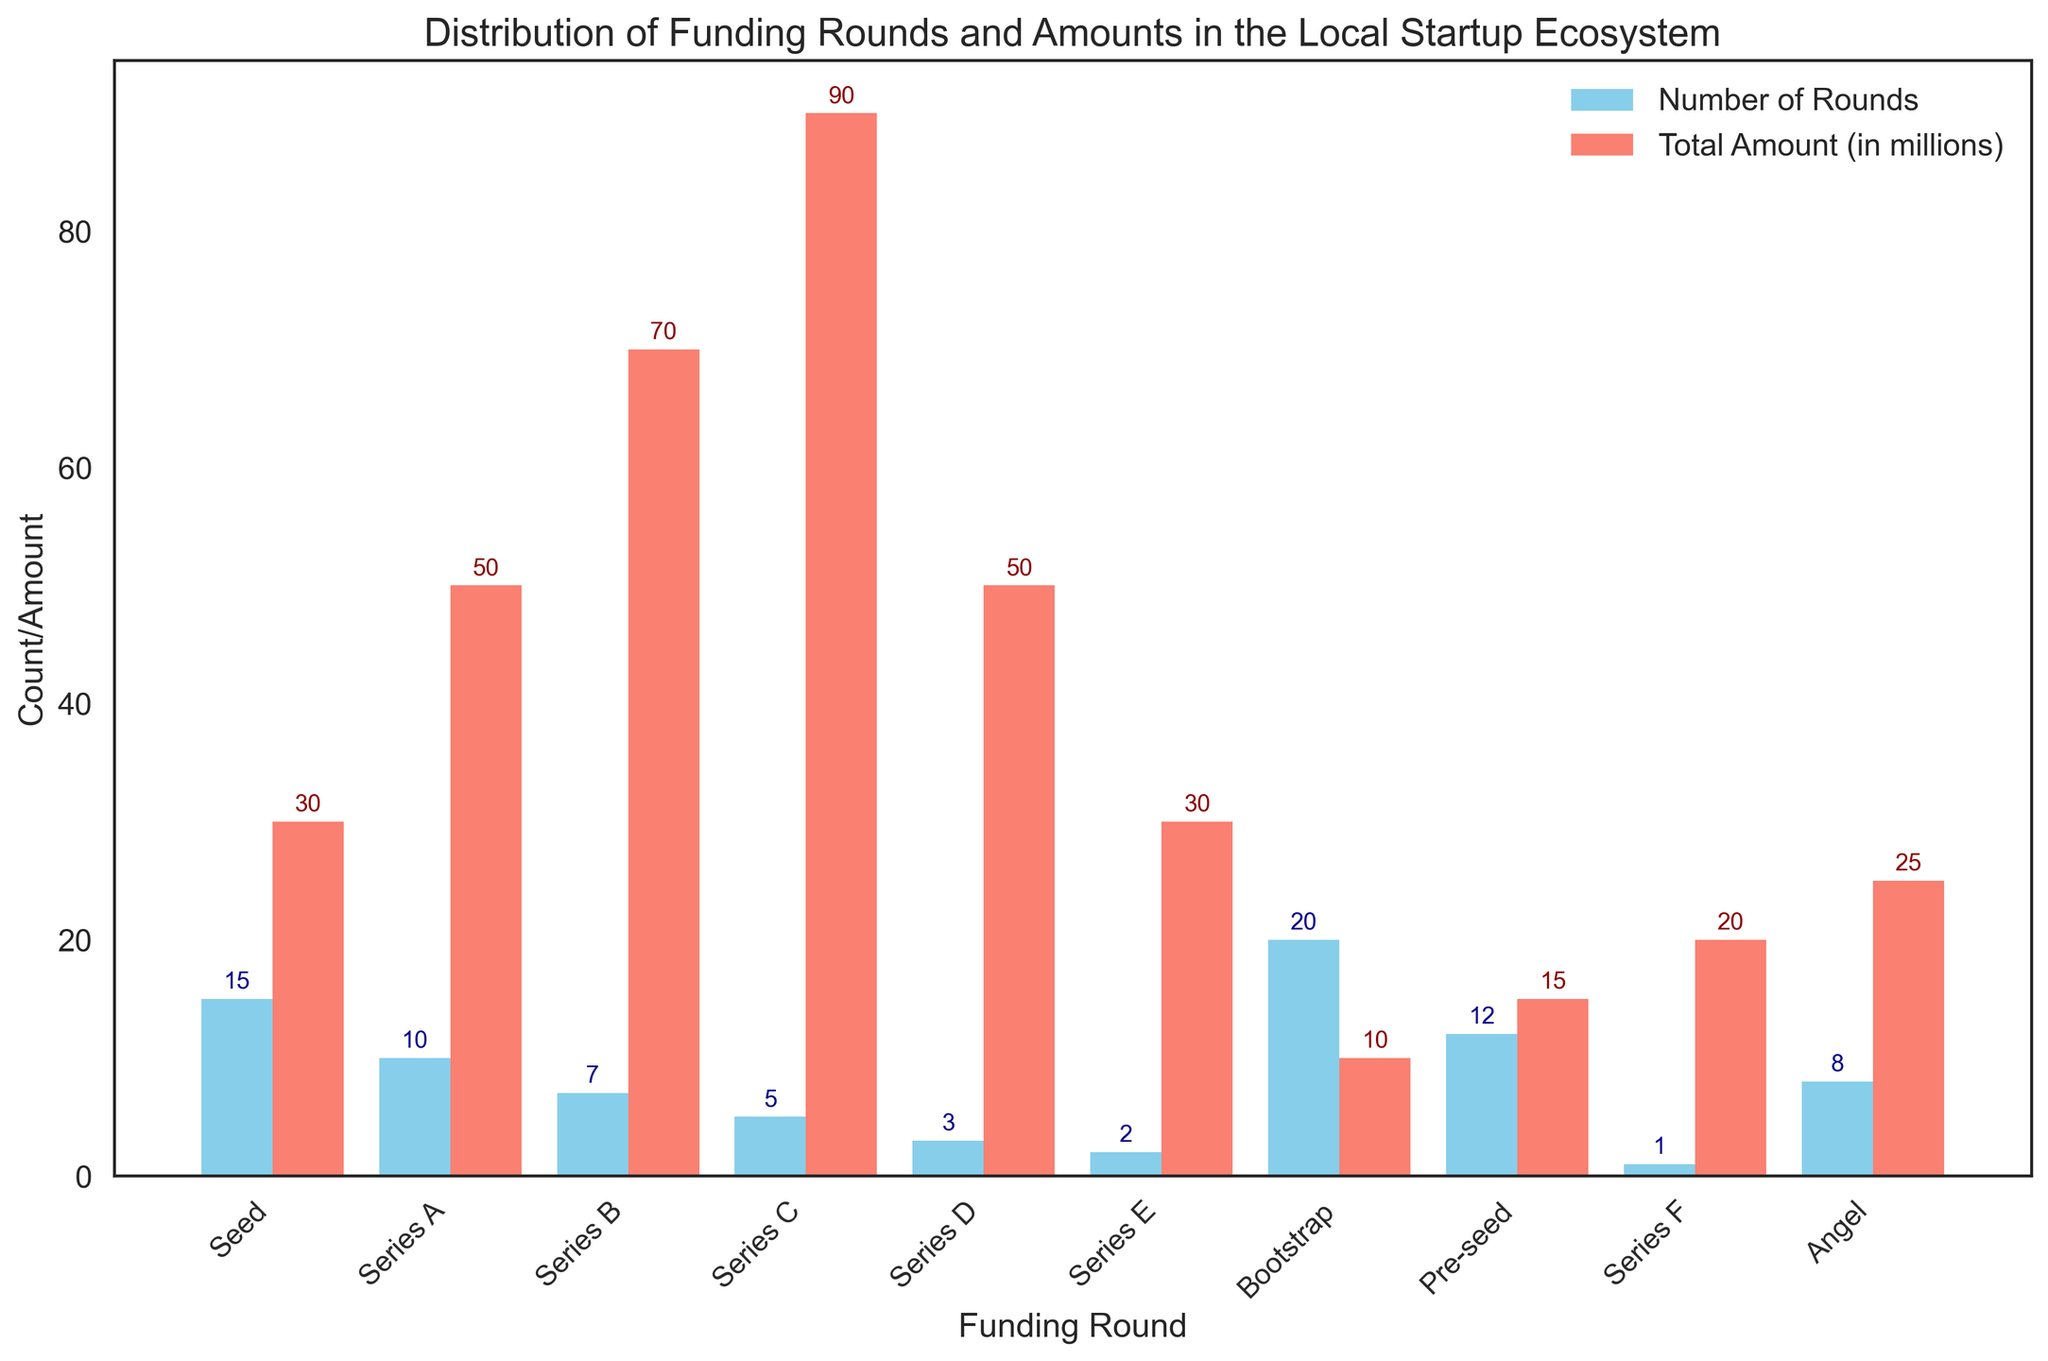What is the funding round with the highest total amount raised? To answer this, look at the 'Total Amount (in millions)' bars and identify the highest one, represented in salmon color. Series C has the highest bar.
Answer: Series C Which funding round has the most number of rounds? Look at the 'Number of Rounds' bars and find the highest one, which is represented in skyblue color. Bootstrap has the highest bar.
Answer: Bootstrap What is the difference in the total amount raised between Series D and Series E? Identify the 'Total Amount (in millions)' for Series D and Series E. Series D is 50 million and Series E is 30 million. Subtract the values: 50 - 30 = 20 million.
Answer: 20 million Which funding round has the least number of rounds and what is that number? Look at the 'Number of Rounds' bars and find the lowest one. Series F has the least number of rounds, which is 1.
Answer: Series F, 1 What is the sum of the total amounts raised for Series A and Series B rounds? Identify the 'Total Amount (in millions)' for Series A and Series B. Series A is 50 million and Series B is 70 million. Add the values: 50 + 70 = 120 million.
Answer: 120 million How does the number of Angel funding rounds compare to Pre-seed rounds? Identify the 'Number of Rounds' for Angel and Pre-seed rounds. Angel has 8 rounds, Pre-seed has 12 rounds; hence, Angel has 4 fewer rounds than Pre-seed.
Answer: Angel has 4 fewer rounds What is the average total amount raised across all funding rounds? Sum up all the 'Total Amount (in millions)' and divide by the number of rounds. The sum is 400 million and there are 10 rounds total: 400 / 10 = 40 million.
Answer: 40 million Which funding round has a higher total amount raised, Seed or Series A, and by how much? Identify the 'Total Amount (in millions)' for Seed and Series A. Seed is 30 million, Series A is 50 million. The difference: 50 - 30 = 20 million.
Answer: Series A, 20 million Which two funding rounds have the same total amount raised, and what is that amount? Identify the 'Total Amount (in millions)' bars and look for the same height. Seed and Series E both have raised 30 million dollars.
Answer: Seed and Series E, 30 million 